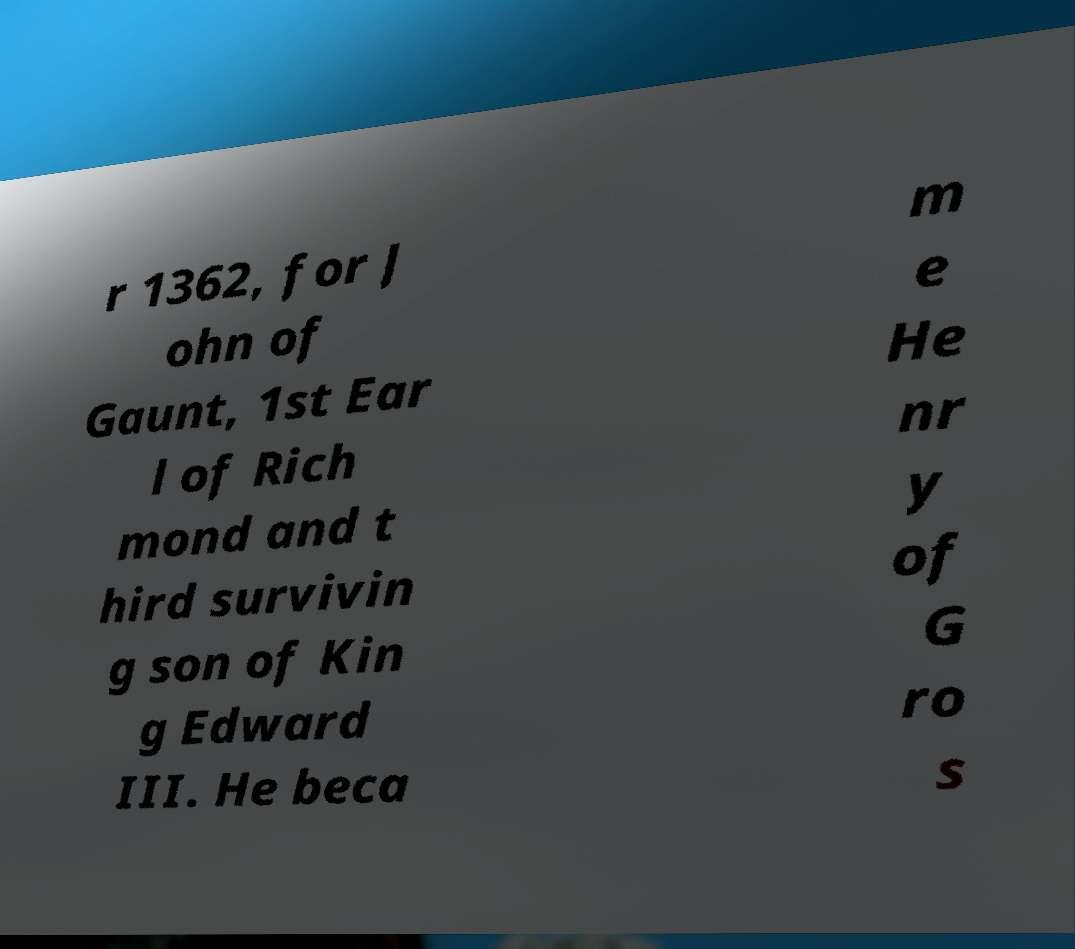Please read and relay the text visible in this image. What does it say? r 1362, for J ohn of Gaunt, 1st Ear l of Rich mond and t hird survivin g son of Kin g Edward III. He beca m e He nr y of G ro s 